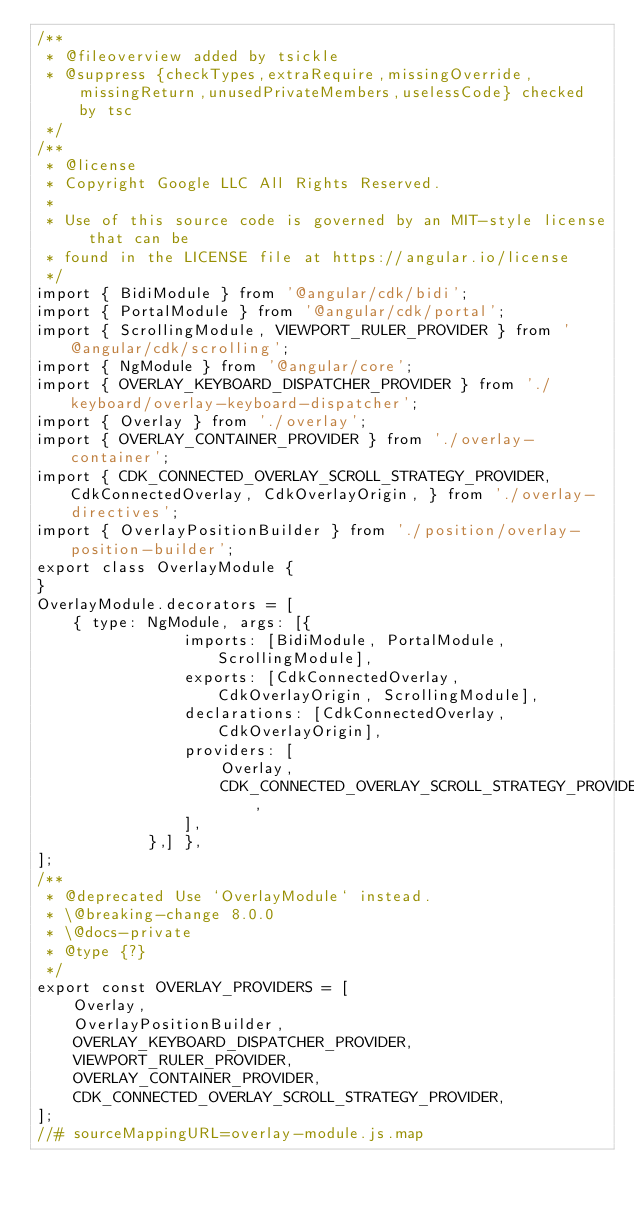Convert code to text. <code><loc_0><loc_0><loc_500><loc_500><_JavaScript_>/**
 * @fileoverview added by tsickle
 * @suppress {checkTypes,extraRequire,missingOverride,missingReturn,unusedPrivateMembers,uselessCode} checked by tsc
 */
/**
 * @license
 * Copyright Google LLC All Rights Reserved.
 *
 * Use of this source code is governed by an MIT-style license that can be
 * found in the LICENSE file at https://angular.io/license
 */
import { BidiModule } from '@angular/cdk/bidi';
import { PortalModule } from '@angular/cdk/portal';
import { ScrollingModule, VIEWPORT_RULER_PROVIDER } from '@angular/cdk/scrolling';
import { NgModule } from '@angular/core';
import { OVERLAY_KEYBOARD_DISPATCHER_PROVIDER } from './keyboard/overlay-keyboard-dispatcher';
import { Overlay } from './overlay';
import { OVERLAY_CONTAINER_PROVIDER } from './overlay-container';
import { CDK_CONNECTED_OVERLAY_SCROLL_STRATEGY_PROVIDER, CdkConnectedOverlay, CdkOverlayOrigin, } from './overlay-directives';
import { OverlayPositionBuilder } from './position/overlay-position-builder';
export class OverlayModule {
}
OverlayModule.decorators = [
    { type: NgModule, args: [{
                imports: [BidiModule, PortalModule, ScrollingModule],
                exports: [CdkConnectedOverlay, CdkOverlayOrigin, ScrollingModule],
                declarations: [CdkConnectedOverlay, CdkOverlayOrigin],
                providers: [
                    Overlay,
                    CDK_CONNECTED_OVERLAY_SCROLL_STRATEGY_PROVIDER,
                ],
            },] },
];
/**
 * @deprecated Use `OverlayModule` instead.
 * \@breaking-change 8.0.0
 * \@docs-private
 * @type {?}
 */
export const OVERLAY_PROVIDERS = [
    Overlay,
    OverlayPositionBuilder,
    OVERLAY_KEYBOARD_DISPATCHER_PROVIDER,
    VIEWPORT_RULER_PROVIDER,
    OVERLAY_CONTAINER_PROVIDER,
    CDK_CONNECTED_OVERLAY_SCROLL_STRATEGY_PROVIDER,
];
//# sourceMappingURL=overlay-module.js.map</code> 